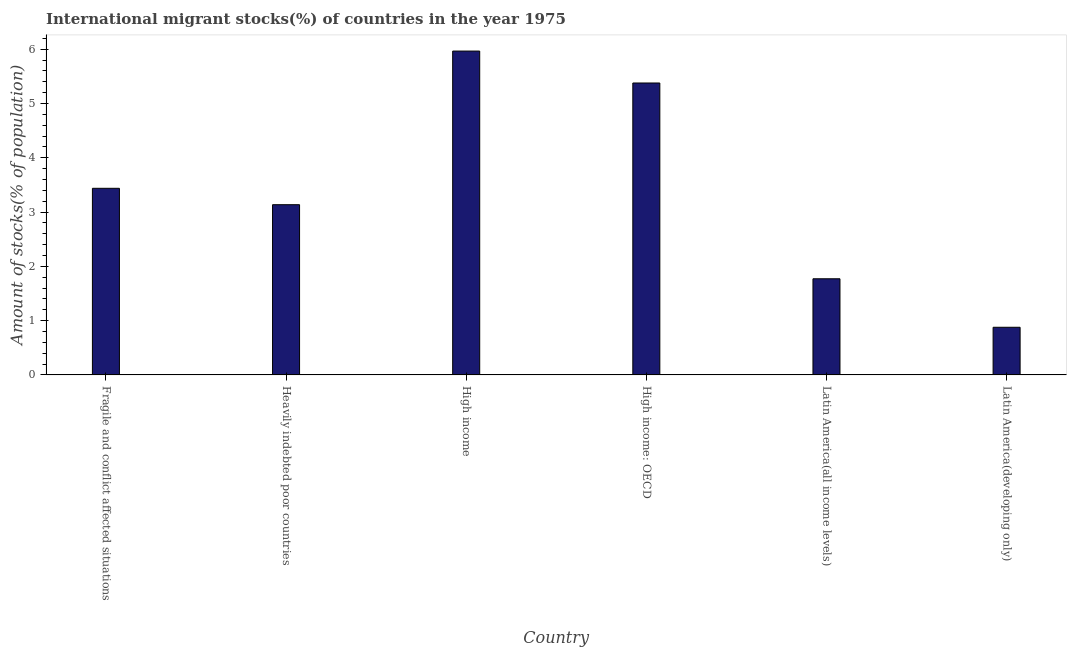Does the graph contain any zero values?
Make the answer very short. No. Does the graph contain grids?
Offer a very short reply. No. What is the title of the graph?
Your response must be concise. International migrant stocks(%) of countries in the year 1975. What is the label or title of the X-axis?
Give a very brief answer. Country. What is the label or title of the Y-axis?
Give a very brief answer. Amount of stocks(% of population). What is the number of international migrant stocks in Latin America(all income levels)?
Keep it short and to the point. 1.77. Across all countries, what is the maximum number of international migrant stocks?
Your answer should be compact. 5.96. Across all countries, what is the minimum number of international migrant stocks?
Make the answer very short. 0.88. In which country was the number of international migrant stocks maximum?
Provide a succinct answer. High income. In which country was the number of international migrant stocks minimum?
Offer a very short reply. Latin America(developing only). What is the sum of the number of international migrant stocks?
Offer a terse response. 20.56. What is the difference between the number of international migrant stocks in Fragile and conflict affected situations and High income: OECD?
Ensure brevity in your answer.  -1.94. What is the average number of international migrant stocks per country?
Give a very brief answer. 3.43. What is the median number of international migrant stocks?
Offer a very short reply. 3.29. In how many countries, is the number of international migrant stocks greater than 1 %?
Make the answer very short. 5. What is the ratio of the number of international migrant stocks in Heavily indebted poor countries to that in High income?
Provide a short and direct response. 0.53. Is the number of international migrant stocks in Heavily indebted poor countries less than that in High income: OECD?
Offer a very short reply. Yes. What is the difference between the highest and the second highest number of international migrant stocks?
Keep it short and to the point. 0.59. Is the sum of the number of international migrant stocks in Fragile and conflict affected situations and High income greater than the maximum number of international migrant stocks across all countries?
Provide a succinct answer. Yes. What is the difference between the highest and the lowest number of international migrant stocks?
Offer a terse response. 5.09. In how many countries, is the number of international migrant stocks greater than the average number of international migrant stocks taken over all countries?
Provide a short and direct response. 3. How many countries are there in the graph?
Provide a short and direct response. 6. Are the values on the major ticks of Y-axis written in scientific E-notation?
Offer a very short reply. No. What is the Amount of stocks(% of population) of Fragile and conflict affected situations?
Your answer should be very brief. 3.44. What is the Amount of stocks(% of population) in Heavily indebted poor countries?
Provide a succinct answer. 3.14. What is the Amount of stocks(% of population) of High income?
Your answer should be compact. 5.96. What is the Amount of stocks(% of population) in High income: OECD?
Provide a short and direct response. 5.38. What is the Amount of stocks(% of population) of Latin America(all income levels)?
Provide a short and direct response. 1.77. What is the Amount of stocks(% of population) in Latin America(developing only)?
Provide a succinct answer. 0.88. What is the difference between the Amount of stocks(% of population) in Fragile and conflict affected situations and Heavily indebted poor countries?
Your answer should be very brief. 0.3. What is the difference between the Amount of stocks(% of population) in Fragile and conflict affected situations and High income?
Make the answer very short. -2.53. What is the difference between the Amount of stocks(% of population) in Fragile and conflict affected situations and High income: OECD?
Make the answer very short. -1.94. What is the difference between the Amount of stocks(% of population) in Fragile and conflict affected situations and Latin America(all income levels)?
Offer a terse response. 1.67. What is the difference between the Amount of stocks(% of population) in Fragile and conflict affected situations and Latin America(developing only)?
Ensure brevity in your answer.  2.56. What is the difference between the Amount of stocks(% of population) in Heavily indebted poor countries and High income?
Your response must be concise. -2.83. What is the difference between the Amount of stocks(% of population) in Heavily indebted poor countries and High income: OECD?
Provide a short and direct response. -2.24. What is the difference between the Amount of stocks(% of population) in Heavily indebted poor countries and Latin America(all income levels)?
Keep it short and to the point. 1.36. What is the difference between the Amount of stocks(% of population) in Heavily indebted poor countries and Latin America(developing only)?
Ensure brevity in your answer.  2.26. What is the difference between the Amount of stocks(% of population) in High income and High income: OECD?
Provide a succinct answer. 0.59. What is the difference between the Amount of stocks(% of population) in High income and Latin America(all income levels)?
Make the answer very short. 4.19. What is the difference between the Amount of stocks(% of population) in High income and Latin America(developing only)?
Your answer should be compact. 5.09. What is the difference between the Amount of stocks(% of population) in High income: OECD and Latin America(all income levels)?
Ensure brevity in your answer.  3.61. What is the difference between the Amount of stocks(% of population) in High income: OECD and Latin America(developing only)?
Provide a succinct answer. 4.5. What is the difference between the Amount of stocks(% of population) in Latin America(all income levels) and Latin America(developing only)?
Provide a short and direct response. 0.89. What is the ratio of the Amount of stocks(% of population) in Fragile and conflict affected situations to that in Heavily indebted poor countries?
Keep it short and to the point. 1.1. What is the ratio of the Amount of stocks(% of population) in Fragile and conflict affected situations to that in High income?
Your answer should be compact. 0.58. What is the ratio of the Amount of stocks(% of population) in Fragile and conflict affected situations to that in High income: OECD?
Ensure brevity in your answer.  0.64. What is the ratio of the Amount of stocks(% of population) in Fragile and conflict affected situations to that in Latin America(all income levels)?
Ensure brevity in your answer.  1.94. What is the ratio of the Amount of stocks(% of population) in Fragile and conflict affected situations to that in Latin America(developing only)?
Your response must be concise. 3.92. What is the ratio of the Amount of stocks(% of population) in Heavily indebted poor countries to that in High income?
Provide a succinct answer. 0.53. What is the ratio of the Amount of stocks(% of population) in Heavily indebted poor countries to that in High income: OECD?
Give a very brief answer. 0.58. What is the ratio of the Amount of stocks(% of population) in Heavily indebted poor countries to that in Latin America(all income levels)?
Your answer should be compact. 1.77. What is the ratio of the Amount of stocks(% of population) in Heavily indebted poor countries to that in Latin America(developing only)?
Your answer should be compact. 3.57. What is the ratio of the Amount of stocks(% of population) in High income to that in High income: OECD?
Your response must be concise. 1.11. What is the ratio of the Amount of stocks(% of population) in High income to that in Latin America(all income levels)?
Keep it short and to the point. 3.37. What is the ratio of the Amount of stocks(% of population) in High income to that in Latin America(developing only)?
Keep it short and to the point. 6.8. What is the ratio of the Amount of stocks(% of population) in High income: OECD to that in Latin America(all income levels)?
Keep it short and to the point. 3.04. What is the ratio of the Amount of stocks(% of population) in High income: OECD to that in Latin America(developing only)?
Your answer should be very brief. 6.13. What is the ratio of the Amount of stocks(% of population) in Latin America(all income levels) to that in Latin America(developing only)?
Make the answer very short. 2.02. 